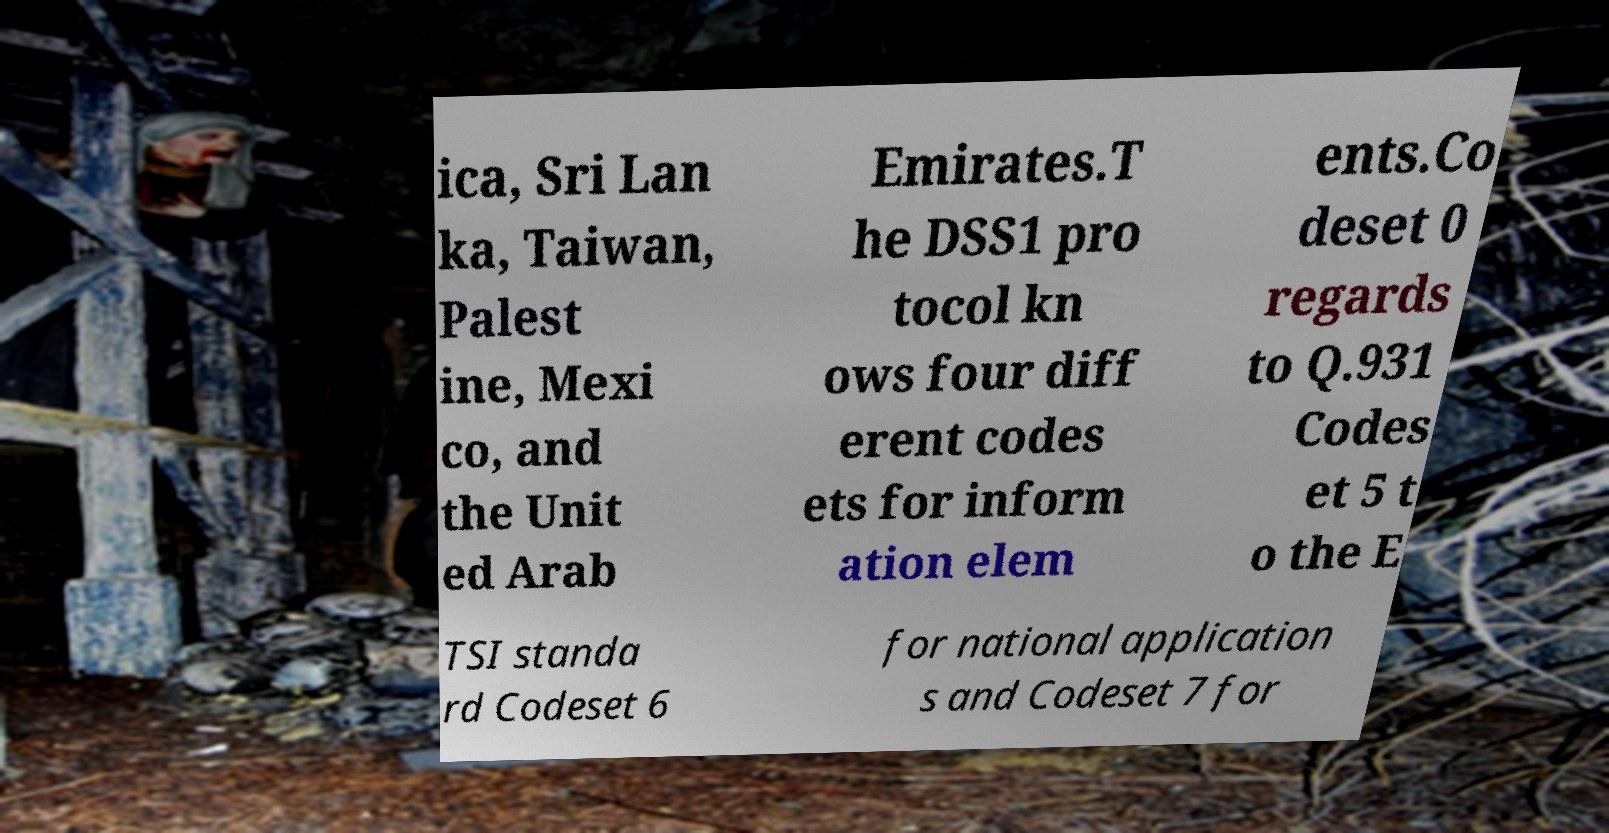Could you assist in decoding the text presented in this image and type it out clearly? ica, Sri Lan ka, Taiwan, Palest ine, Mexi co, and the Unit ed Arab Emirates.T he DSS1 pro tocol kn ows four diff erent codes ets for inform ation elem ents.Co deset 0 regards to Q.931 Codes et 5 t o the E TSI standa rd Codeset 6 for national application s and Codeset 7 for 